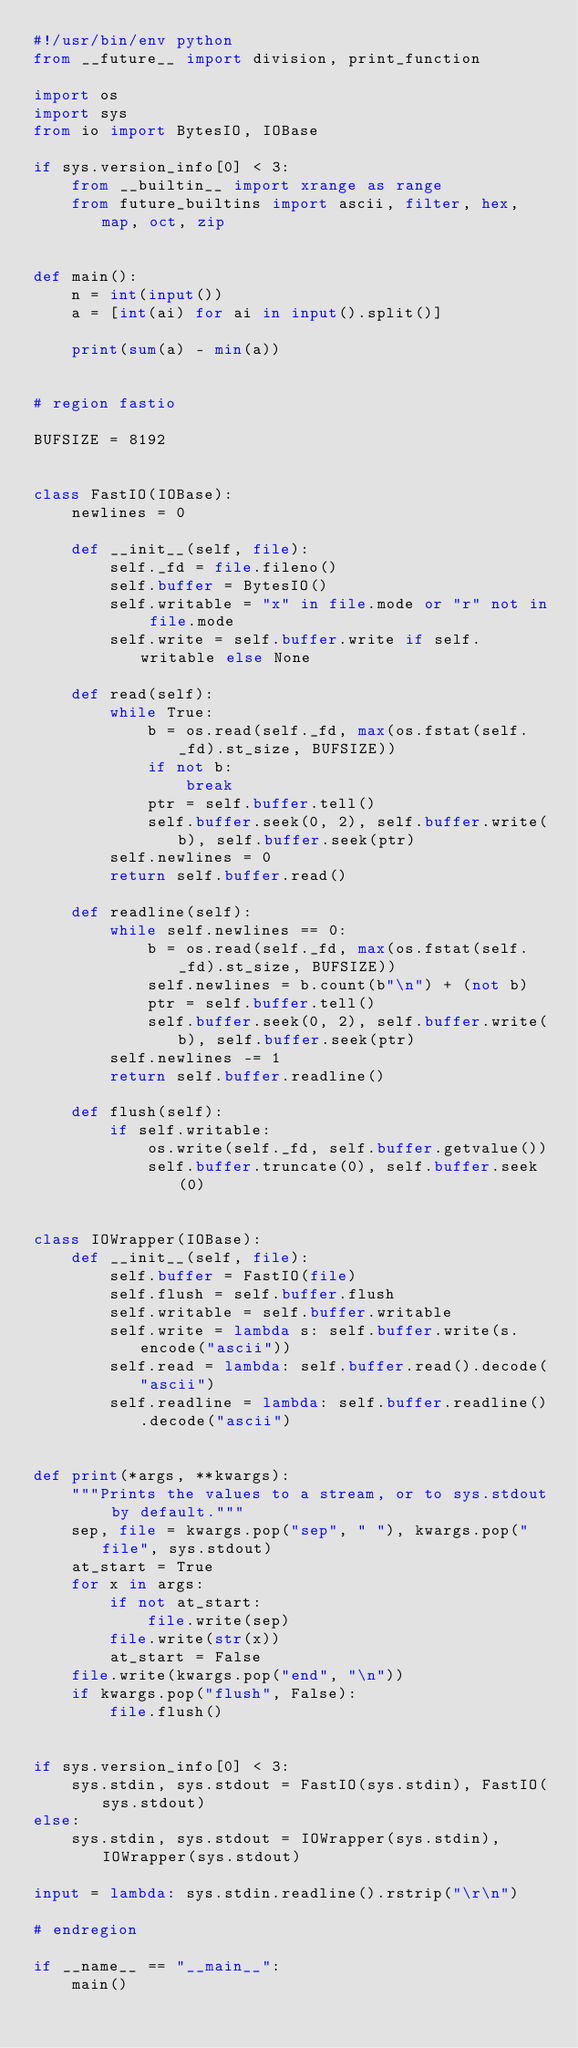Convert code to text. <code><loc_0><loc_0><loc_500><loc_500><_Python_>#!/usr/bin/env python
from __future__ import division, print_function

import os
import sys
from io import BytesIO, IOBase

if sys.version_info[0] < 3:
    from __builtin__ import xrange as range
    from future_builtins import ascii, filter, hex, map, oct, zip


def main():
    n = int(input())
    a = [int(ai) for ai in input().split()]

    print(sum(a) - min(a))


# region fastio

BUFSIZE = 8192


class FastIO(IOBase):
    newlines = 0

    def __init__(self, file):
        self._fd = file.fileno()
        self.buffer = BytesIO()
        self.writable = "x" in file.mode or "r" not in file.mode
        self.write = self.buffer.write if self.writable else None

    def read(self):
        while True:
            b = os.read(self._fd, max(os.fstat(self._fd).st_size, BUFSIZE))
            if not b:
                break
            ptr = self.buffer.tell()
            self.buffer.seek(0, 2), self.buffer.write(b), self.buffer.seek(ptr)
        self.newlines = 0
        return self.buffer.read()

    def readline(self):
        while self.newlines == 0:
            b = os.read(self._fd, max(os.fstat(self._fd).st_size, BUFSIZE))
            self.newlines = b.count(b"\n") + (not b)
            ptr = self.buffer.tell()
            self.buffer.seek(0, 2), self.buffer.write(b), self.buffer.seek(ptr)
        self.newlines -= 1
        return self.buffer.readline()

    def flush(self):
        if self.writable:
            os.write(self._fd, self.buffer.getvalue())
            self.buffer.truncate(0), self.buffer.seek(0)


class IOWrapper(IOBase):
    def __init__(self, file):
        self.buffer = FastIO(file)
        self.flush = self.buffer.flush
        self.writable = self.buffer.writable
        self.write = lambda s: self.buffer.write(s.encode("ascii"))
        self.read = lambda: self.buffer.read().decode("ascii")
        self.readline = lambda: self.buffer.readline().decode("ascii")


def print(*args, **kwargs):
    """Prints the values to a stream, or to sys.stdout by default."""
    sep, file = kwargs.pop("sep", " "), kwargs.pop("file", sys.stdout)
    at_start = True
    for x in args:
        if not at_start:
            file.write(sep)
        file.write(str(x))
        at_start = False
    file.write(kwargs.pop("end", "\n"))
    if kwargs.pop("flush", False):
        file.flush()


if sys.version_info[0] < 3:
    sys.stdin, sys.stdout = FastIO(sys.stdin), FastIO(sys.stdout)
else:
    sys.stdin, sys.stdout = IOWrapper(sys.stdin), IOWrapper(sys.stdout)

input = lambda: sys.stdin.readline().rstrip("\r\n")

# endregion

if __name__ == "__main__":
    main()
</code> 